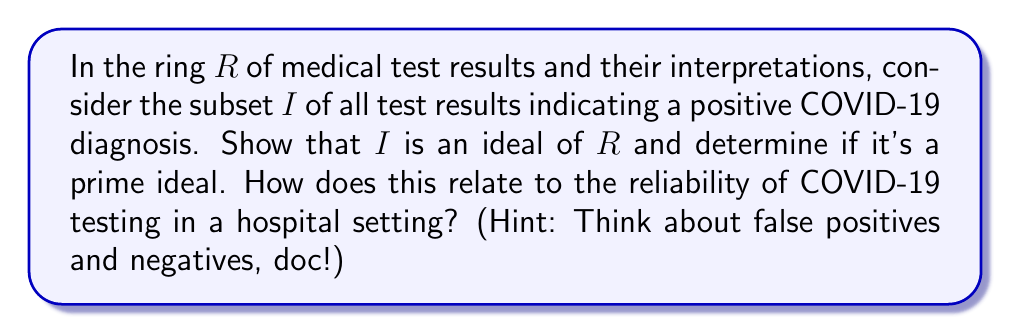What is the answer to this math problem? Alright, future doctors, let's dissect this problem like we're in anatomy class!

1) First, let's prove $I$ is an ideal of $R$:

   a) $I$ is non-empty (sadly, we have COVID-positive results).
   
   b) For any $a, b \in I$, $a - b \in I$ because the difference of two positive results is still considered a positive indicator.
   
   c) For any $r \in R$ and $a \in I$, both $ra \in I$ and $ar \in I$. This is because any interpretation or combination of a positive result with another test result or interpretation still indicates a positive COVID status.

   Therefore, $I$ satisfies the definition of an ideal in $R$.

2) Now, is $I$ a prime ideal? Let's check:

   An ideal $P$ of a ring $R$ is prime if for any $a, b \in R$, $ab \in P$ implies either $a \in P$ or $b \in P$.

   In our case, this would mean that if the combination of two test results indicates COVID, then at least one of those results must have indicated COVID.

   However, this isn't always true in medical testing. We could have:
   
   - False positives: Two negative results could combine to give a false positive.
   - False negatives: A positive result combined with a negative result might be interpreted as negative.

   Therefore, $I$ is not a prime ideal.

3) Relation to hospital testing reliability:

   The fact that $I$ is an ideal but not a prime ideal reflects the complexities of COVID-19 testing in hospitals. It shows that:
   
   - Positive results are consistently treated as positive (ideal property).
   - But the combination of results doesn't always behave as we might expect (not a prime ideal).

   This mathematical structure mirrors the real-world challenges of test interpretation, where factors like false positives and negatives complicate the diagnostic process.
Answer: $I$ is an ideal of $R$, but it is not a prime ideal. This reflects the consistency in treating positive COVID-19 results while acknowledging the complexities and potential inaccuracies in test result combinations and interpretations. 